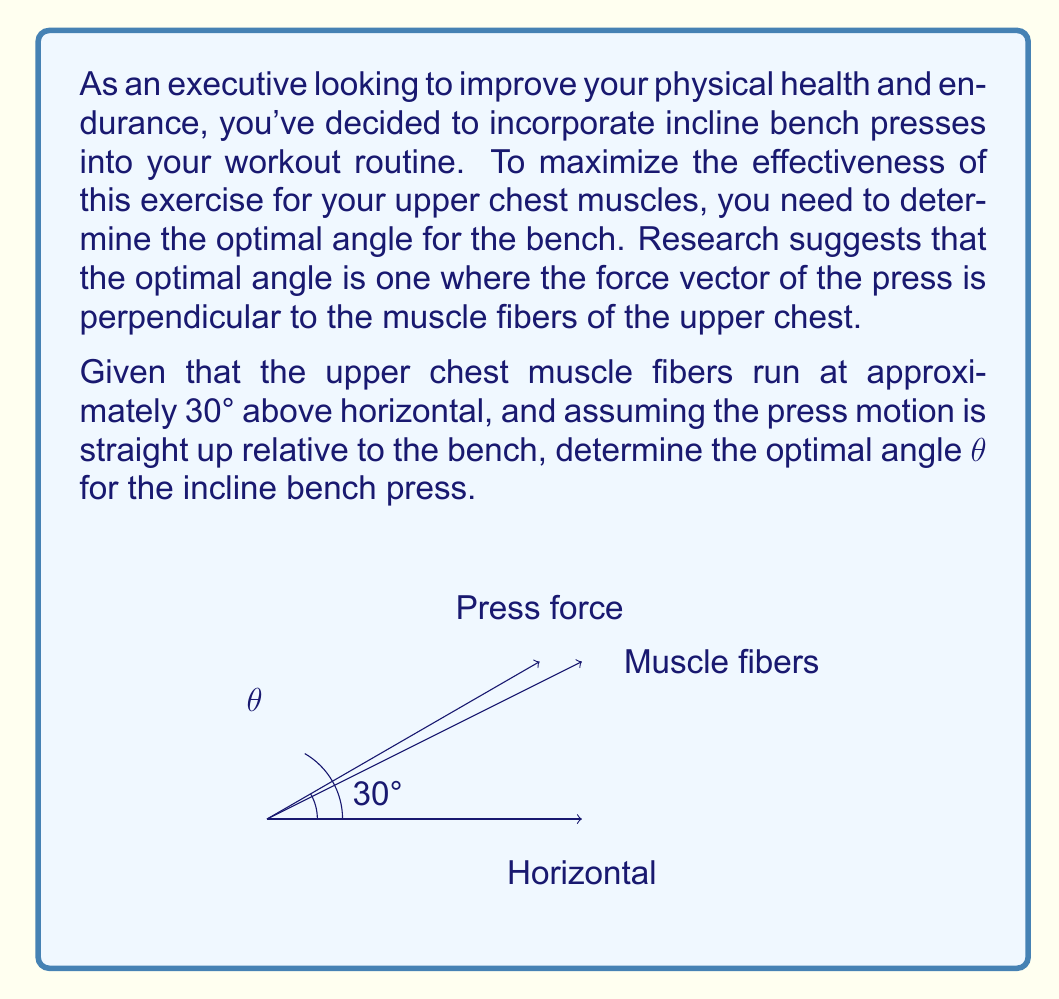Teach me how to tackle this problem. To solve this problem, we'll use trigonometry and vector principles:

1) The muscle fibers are at a 30° angle from horizontal. For optimal activation, the press force should be perpendicular (90°) to these fibers.

2) Let's define the angle of the incline bench as θ. The press force will be perpendicular to the bench, so it will be at an angle of (90° + θ) from horizontal.

3) For the press force to be perpendicular to the muscle fibers, we need:

   $$(90° + θ) - 30° = 90°$$

4) Simplifying:
   
   $$θ + 60° = 90°$$
   $$θ = 90° - 60° = 30°$$

5) We can verify this geometrically:
   - The muscle fibers are at 30° from horizontal
   - The bench is at 30° from horizontal
   - The press force is at 90° from the bench, which is 120° from horizontal
   - The angle between the press force and muscle fibers is indeed 90° (120° - 30°)

This angle ensures that the force applied during the incline bench press is optimal for targeting the upper chest muscles, which is crucial for an executive looking to efficiently improve physical health and endurance.
Answer: The optimal angle for the incline bench press is $θ = 30°$. 